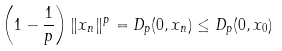<formula> <loc_0><loc_0><loc_500><loc_500>\left ( 1 - \frac { 1 } { p } \right ) \| x _ { n } \| ^ { p } = D _ { p } ( 0 , x _ { n } ) \leq D _ { p } ( 0 , x _ { 0 } )</formula> 